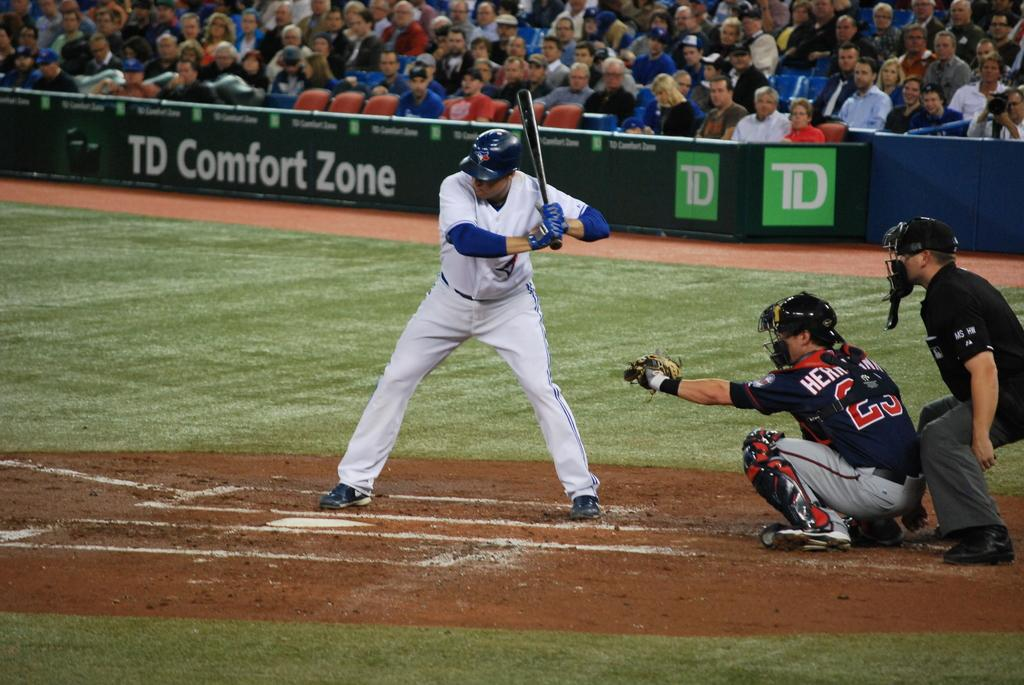<image>
Provide a brief description of the given image. A baseball player is at bat with the catcher and umpire behind him, all in front of a TD Comfort Zone sign. 